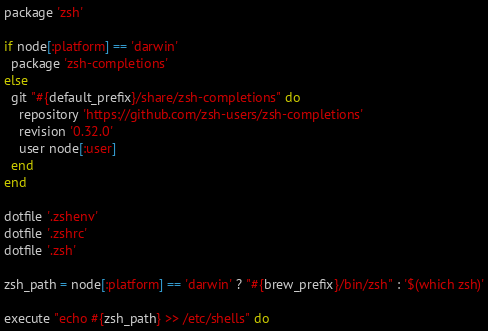Convert code to text. <code><loc_0><loc_0><loc_500><loc_500><_Ruby_>package 'zsh'

if node[:platform] == 'darwin'
  package 'zsh-completions'
else
  git "#{default_prefix}/share/zsh-completions" do
    repository 'https://github.com/zsh-users/zsh-completions'
    revision '0.32.0'
    user node[:user]
  end
end

dotfile '.zshenv'
dotfile '.zshrc'
dotfile '.zsh'

zsh_path = node[:platform] == 'darwin' ? "#{brew_prefix}/bin/zsh" : '$(which zsh)'

execute "echo #{zsh_path} >> /etc/shells" do</code> 